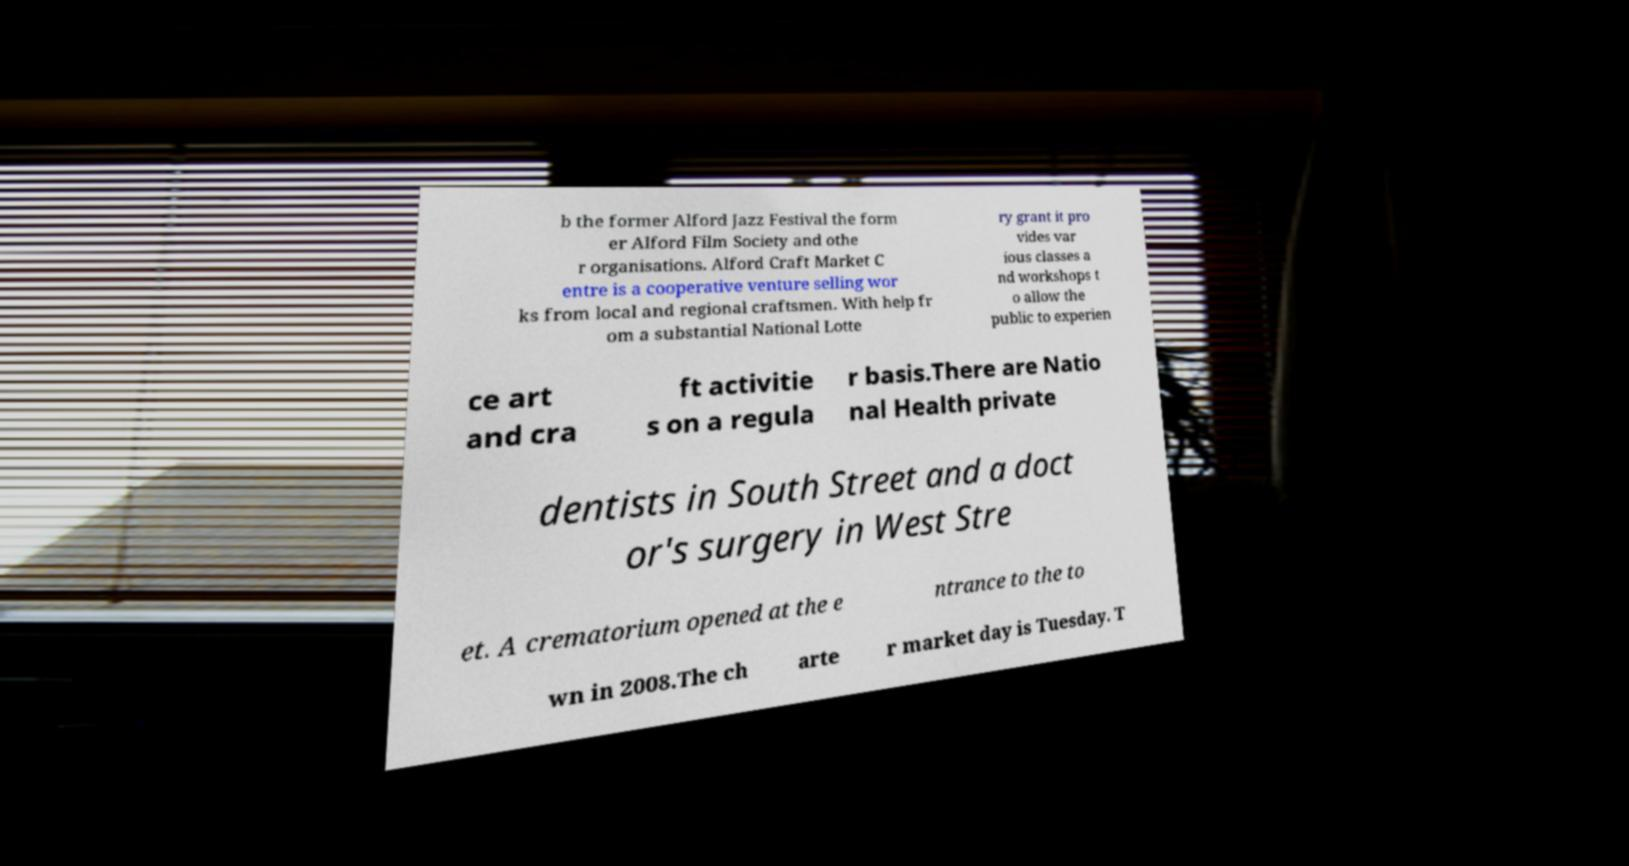Please read and relay the text visible in this image. What does it say? b the former Alford Jazz Festival the form er Alford Film Society and othe r organisations. Alford Craft Market C entre is a cooperative venture selling wor ks from local and regional craftsmen. With help fr om a substantial National Lotte ry grant it pro vides var ious classes a nd workshops t o allow the public to experien ce art and cra ft activitie s on a regula r basis.There are Natio nal Health private dentists in South Street and a doct or's surgery in West Stre et. A crematorium opened at the e ntrance to the to wn in 2008.The ch arte r market day is Tuesday. T 